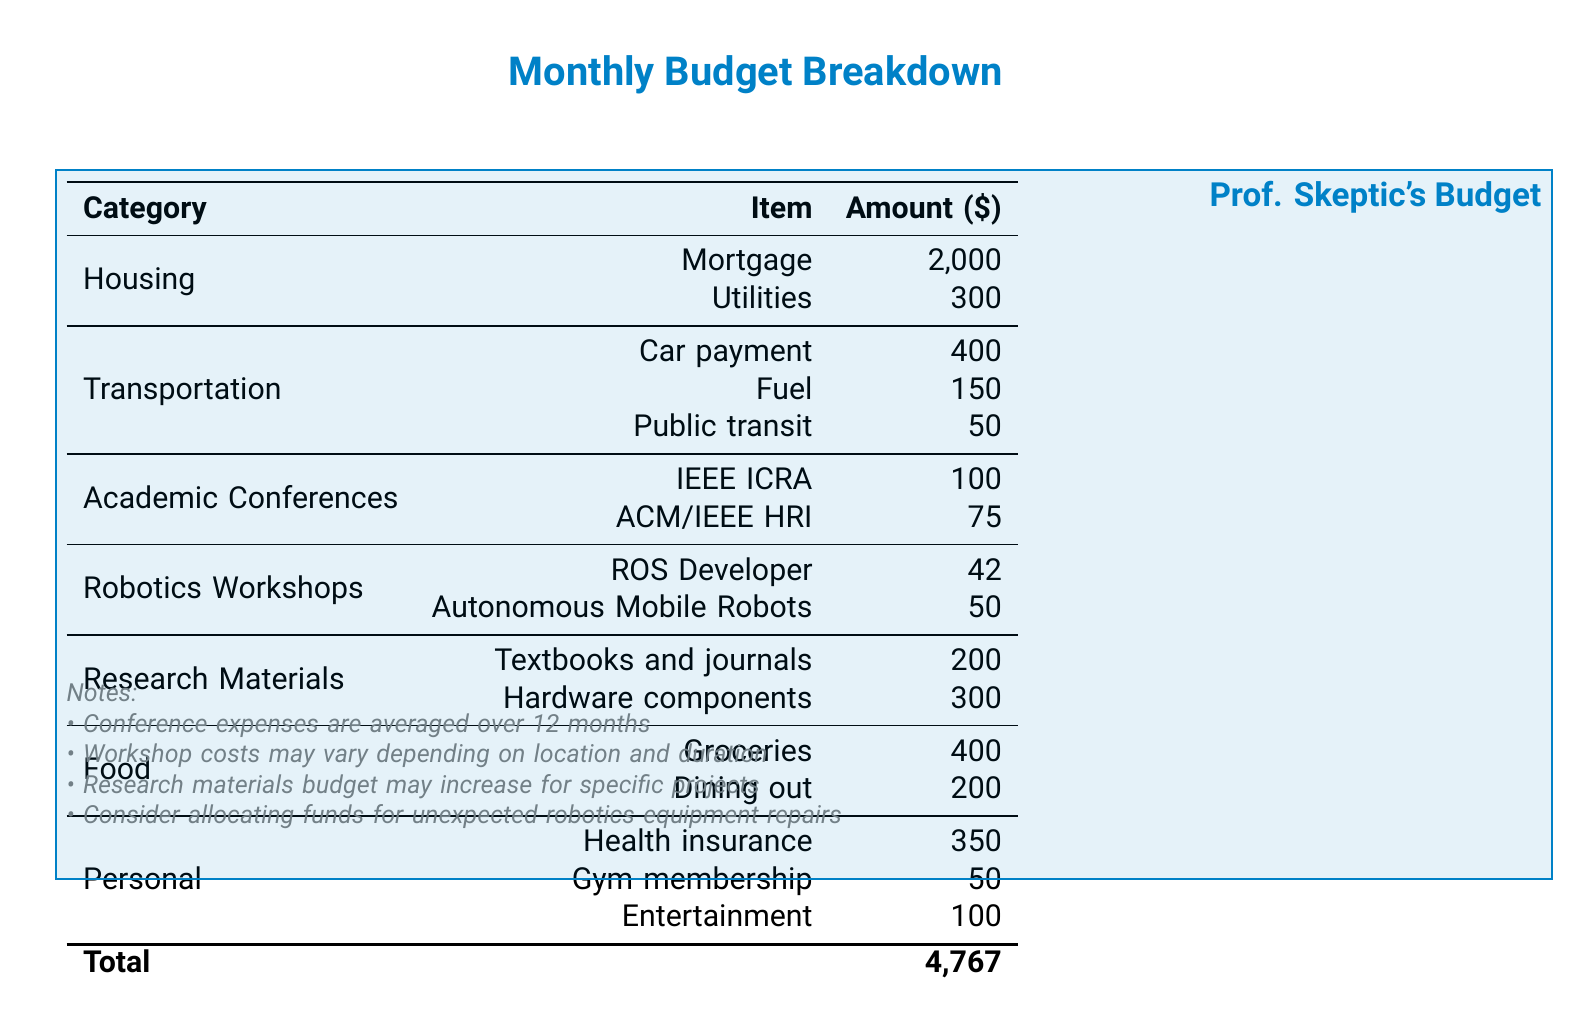What is the total amount spent on academic conferences? The total amount spent on academic conferences is the sum of the expenses for IEEE ICRA and ACM/IEEE HRI, which is $100 + $75.
Answer: $175 How much is allocated for the Autonomous Mobile Robots workshop? The amount allocated for the Autonomous Mobile Robots workshop is listed in the robotics workshops section.
Answer: $50 What are the expenses for food categorized in this budget? The food expenses include groceries and dining out, which are mentioned in the food section.
Answer: Groceries and Dining out What is the total amount for personal expenses? The total amount for personal expenses is the sum of health insurance, gym membership, and entertainment, $350 + $50 + $100.
Answer: $500 How much is spent on research materials? The total spent on research materials is the sum of textbooks and journals and hardware components, which is $200 + $300.
Answer: $500 What is the budget for utilities? The budget for utilities is specified in the housing section of the budget.
Answer: $300 How many categories of expenses are listed in this budget? The categories listed in the budget include Housing, Transportation, Academic Conferences, Robotics Workshops, Research Materials, Food, and Personal.
Answer: 7 What is the total budget amount for the month? The total budget amount is the sum of all the expenses listed in the document.
Answer: $4,767 What is the expense for health insurance? The document specifies the expense for health insurance under the personal category.
Answer: $350 What is the purpose of notes at the bottom of the document? The notes provide additional information and considerations regarding the expenses listed in the budget.
Answer: Additional information 